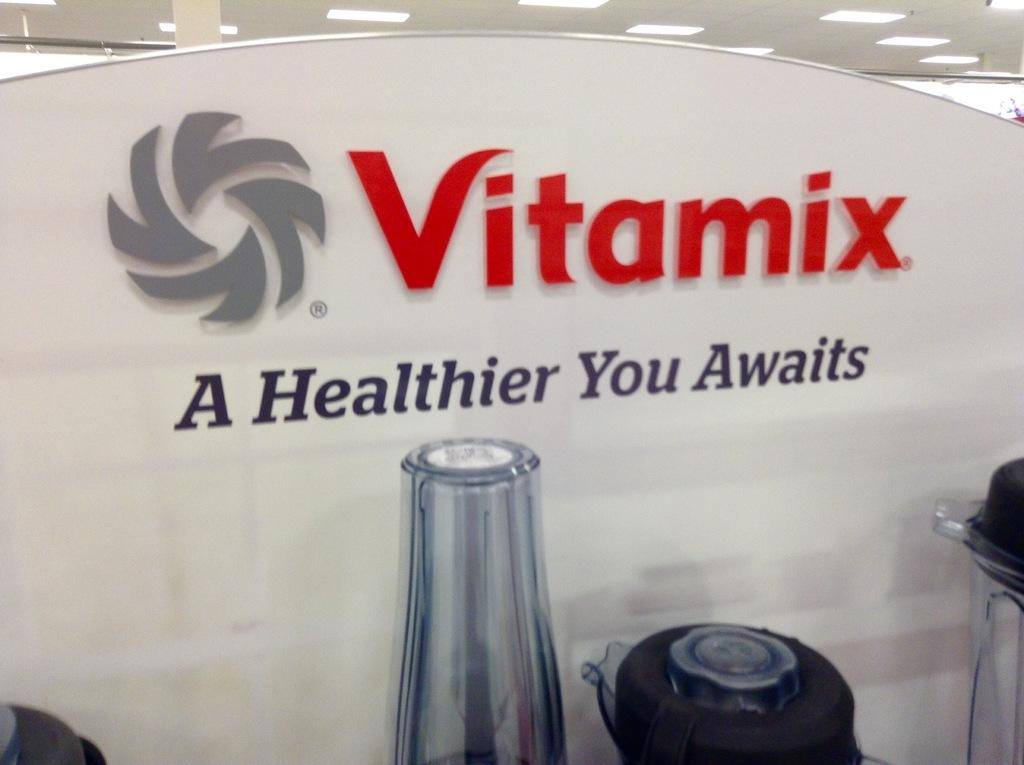What can be seen in the image that resembles storage units? There is a group of containers in the image. What is written on the board in the image? There is a board with "Vitamix" written on it in the image. What can be seen in the background of the image? There is a group of lights in the background of the image. What type of jeans is the minister wearing in the image? There is no minister or jeans present in the image. How does the grip of the container in the image work? The image does not show any specific container with a grip, so it is not possible to answer that question. 